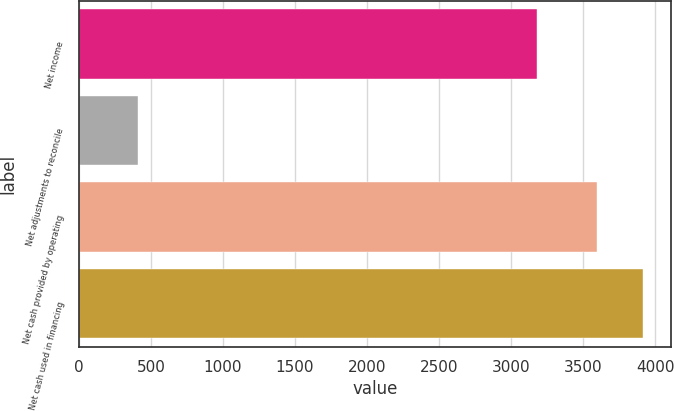Convert chart. <chart><loc_0><loc_0><loc_500><loc_500><bar_chart><fcel>Net income<fcel>Net adjustments to reconcile<fcel>Net cash provided by operating<fcel>Net cash used in financing<nl><fcel>3182<fcel>412<fcel>3594<fcel>3912.2<nl></chart> 